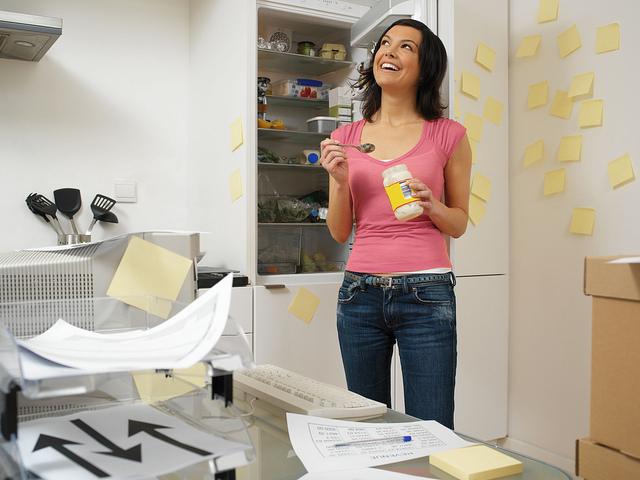What are the yellow squares on the wall?
Keep it brief. Post it notes. What is the color of her shirt?
Write a very short answer. Pink. What is the person holding?
Write a very short answer. Jar. Is her hair is real or duplicate?
Give a very brief answer. Real. 